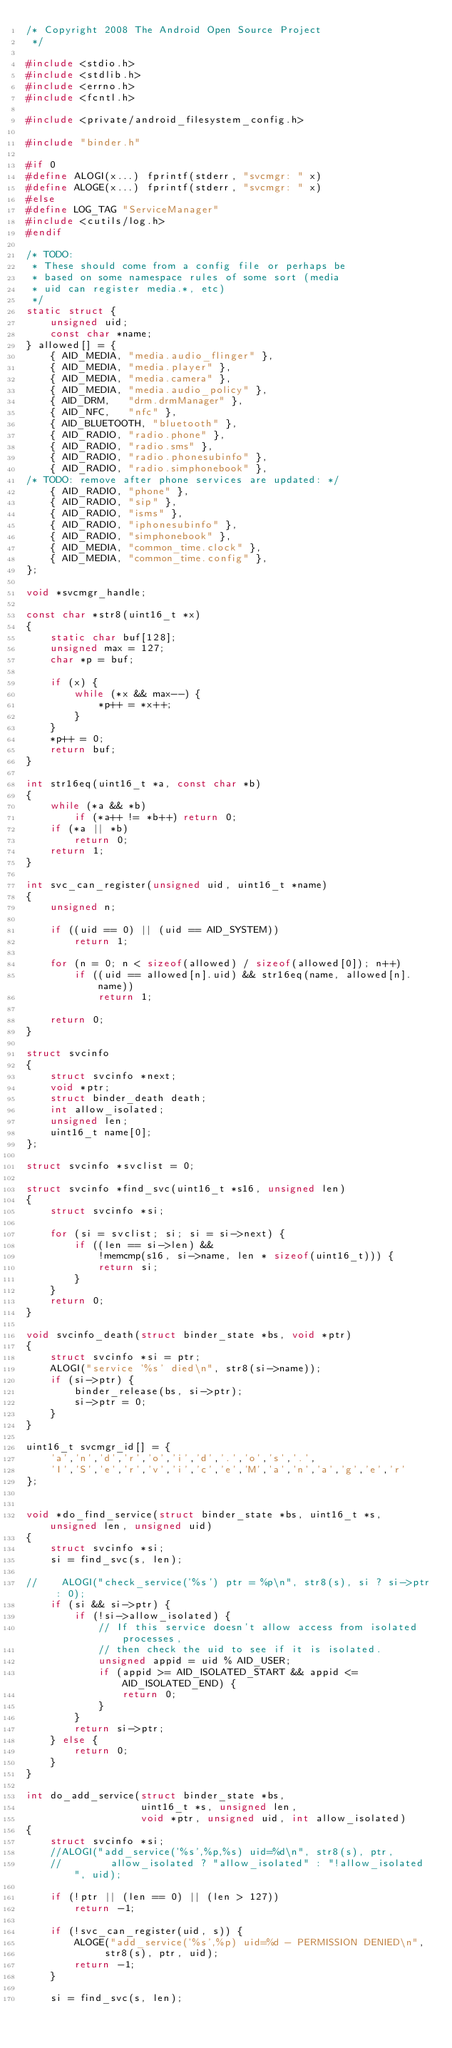<code> <loc_0><loc_0><loc_500><loc_500><_C_>/* Copyright 2008 The Android Open Source Project
 */

#include <stdio.h>
#include <stdlib.h>
#include <errno.h>
#include <fcntl.h>

#include <private/android_filesystem_config.h>

#include "binder.h"

#if 0
#define ALOGI(x...) fprintf(stderr, "svcmgr: " x)
#define ALOGE(x...) fprintf(stderr, "svcmgr: " x)
#else
#define LOG_TAG "ServiceManager"
#include <cutils/log.h>
#endif

/* TODO:
 * These should come from a config file or perhaps be
 * based on some namespace rules of some sort (media
 * uid can register media.*, etc)
 */
static struct {
    unsigned uid;
    const char *name;
} allowed[] = {
    { AID_MEDIA, "media.audio_flinger" },
    { AID_MEDIA, "media.player" },
    { AID_MEDIA, "media.camera" },
    { AID_MEDIA, "media.audio_policy" },
    { AID_DRM,   "drm.drmManager" },
    { AID_NFC,   "nfc" },
    { AID_BLUETOOTH, "bluetooth" },
    { AID_RADIO, "radio.phone" },
    { AID_RADIO, "radio.sms" },
    { AID_RADIO, "radio.phonesubinfo" },
    { AID_RADIO, "radio.simphonebook" },
/* TODO: remove after phone services are updated: */
    { AID_RADIO, "phone" },
    { AID_RADIO, "sip" },
    { AID_RADIO, "isms" },
    { AID_RADIO, "iphonesubinfo" },
    { AID_RADIO, "simphonebook" },
    { AID_MEDIA, "common_time.clock" },
    { AID_MEDIA, "common_time.config" },
};

void *svcmgr_handle;

const char *str8(uint16_t *x)
{
    static char buf[128];
    unsigned max = 127;
    char *p = buf;

    if (x) {
        while (*x && max--) {
            *p++ = *x++;
        }
    }
    *p++ = 0;
    return buf;
}

int str16eq(uint16_t *a, const char *b)
{
    while (*a && *b)
        if (*a++ != *b++) return 0;
    if (*a || *b)
        return 0;
    return 1;
}

int svc_can_register(unsigned uid, uint16_t *name)
{
    unsigned n;
    
    if ((uid == 0) || (uid == AID_SYSTEM))
        return 1;

    for (n = 0; n < sizeof(allowed) / sizeof(allowed[0]); n++)
        if ((uid == allowed[n].uid) && str16eq(name, allowed[n].name))
            return 1;

    return 0;
}

struct svcinfo 
{
    struct svcinfo *next;
    void *ptr;
    struct binder_death death;
    int allow_isolated;
    unsigned len;
    uint16_t name[0];
};

struct svcinfo *svclist = 0;

struct svcinfo *find_svc(uint16_t *s16, unsigned len)
{
    struct svcinfo *si;

    for (si = svclist; si; si = si->next) {
        if ((len == si->len) &&
            !memcmp(s16, si->name, len * sizeof(uint16_t))) {
            return si;
        }
    }
    return 0;
}

void svcinfo_death(struct binder_state *bs, void *ptr)
{
    struct svcinfo *si = ptr;
    ALOGI("service '%s' died\n", str8(si->name));
    if (si->ptr) {
        binder_release(bs, si->ptr);
        si->ptr = 0;
    }   
}

uint16_t svcmgr_id[] = { 
    'a','n','d','r','o','i','d','.','o','s','.',
    'I','S','e','r','v','i','c','e','M','a','n','a','g','e','r' 
};
  

void *do_find_service(struct binder_state *bs, uint16_t *s, unsigned len, unsigned uid)
{
    struct svcinfo *si;
    si = find_svc(s, len);

//    ALOGI("check_service('%s') ptr = %p\n", str8(s), si ? si->ptr : 0);
    if (si && si->ptr) {
        if (!si->allow_isolated) {
            // If this service doesn't allow access from isolated processes,
            // then check the uid to see if it is isolated.
            unsigned appid = uid % AID_USER;
            if (appid >= AID_ISOLATED_START && appid <= AID_ISOLATED_END) {
                return 0;
            }
        }
        return si->ptr;
    } else {
        return 0;
    }
}

int do_add_service(struct binder_state *bs,
                   uint16_t *s, unsigned len,
                   void *ptr, unsigned uid, int allow_isolated)
{
    struct svcinfo *si;
    //ALOGI("add_service('%s',%p,%s) uid=%d\n", str8(s), ptr,
    //        allow_isolated ? "allow_isolated" : "!allow_isolated", uid);

    if (!ptr || (len == 0) || (len > 127))
        return -1;

    if (!svc_can_register(uid, s)) {
        ALOGE("add_service('%s',%p) uid=%d - PERMISSION DENIED\n",
             str8(s), ptr, uid);
        return -1;
    }

    si = find_svc(s, len);</code> 